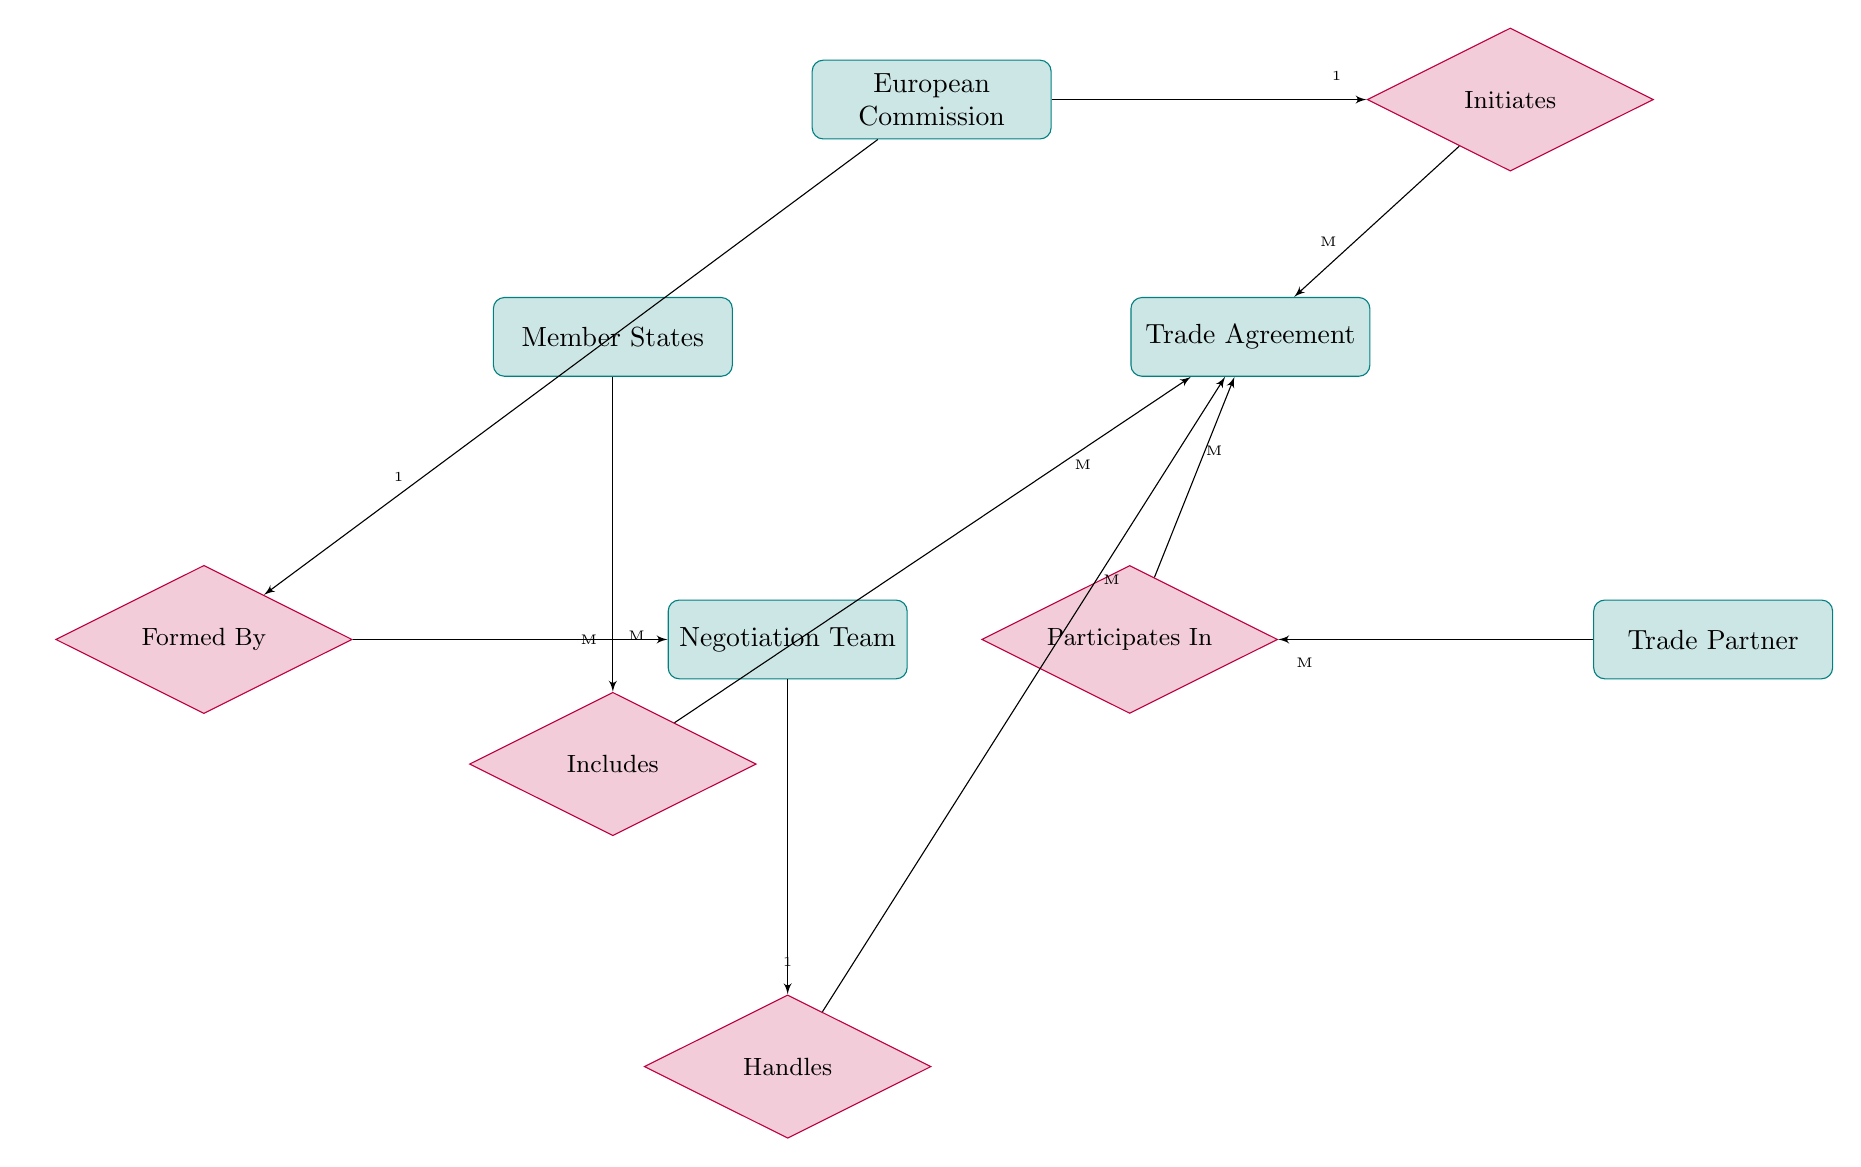How many entities are in the diagram? The diagram contains five entities: European Commission, Member States, Trade Agreement, Trade Partner, and Negotiation Team.
Answer: 5 What is the relationship between European Commission and Trade Agreement? The European Commission initiates Trade Agreements, indicating a one-to-many relationship where one European Commission can initiate many Trade Agreements.
Answer: Initiates How many Member States can include a Trade Agreement? The diagram indicates a many-to-many relationship between Member States and Trade Agreements, suggesting that multiple Member States can include multiple Trade Agreements.
Answer: M Who forms the Negotiation Team? The European Commission forms the Negotiation Team, establishing a one-to-many relationship where one European Commission can form multiple Negotiation Teams.
Answer: Formed By What relationship exists between Trade Partner and Trade Agreement? The relationship is "Participates In," indicating a many-to-many connection between Trade Partners and Trade Agreements, meaning multiple Trade Partners can participate in multiple Trade Agreements.
Answer: Participates In What is the cardinality between Negotiation Team and Trade Agreement? The diagram shows that one Negotiation Team handles many Trade Agreements, illustrating a one-to-many relationship.
Answer: M How does the European Commission engage in Trade Agreements? The diagram shows that the European Commission initiates Trade Agreements and forms Negotiation Teams that handle these agreements, illustrating a structured approach to engagement.
Answer: Initiates, Formed By, Handles Can a Trade Agreement be handled by multiple Negotiation Teams? No, the diagram indicates a one-to-many relationship where each Negotiation Team handles multiple Trade Agreements, but each Trade Agreement is handled by a single Negotiation Team.
Answer: No 